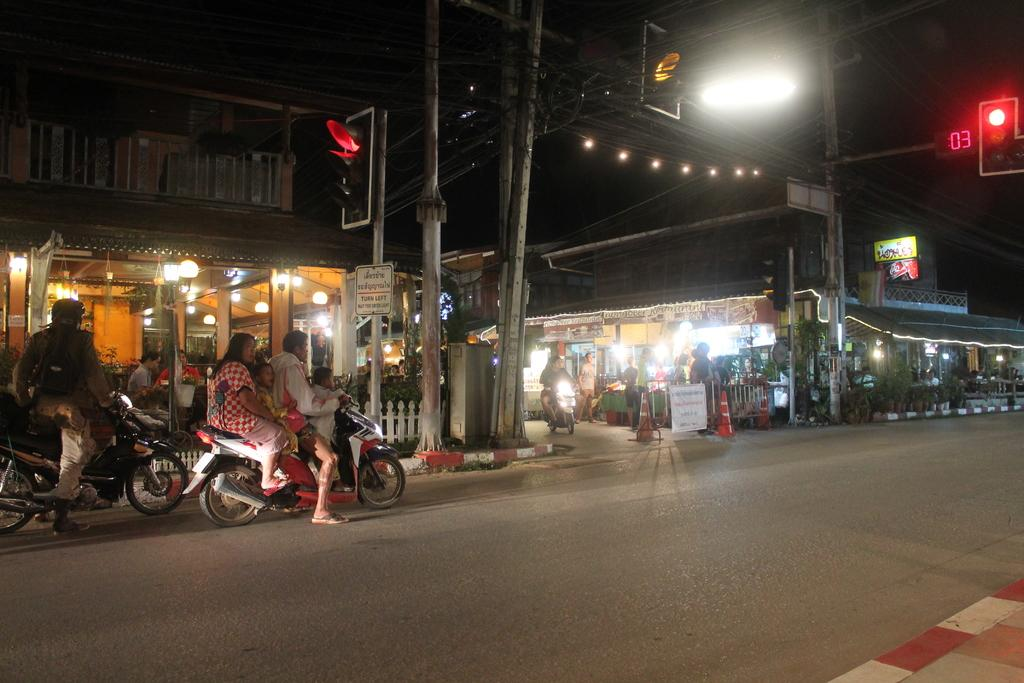What type of structures can be seen in the image? There are buildings in the image. What can be seen illuminating the scene in the image? There are lights in the image. What helps regulate traffic in the image? There are traffic signals in the image. Who is present in the image? There are people in the image. What are some people doing in the image? Some people are sitting on motorcycles. What type of ice can be seen melting on the traffic signals in the image? There is no ice present on the traffic signals in the image. What rule do the people on motorcycles need to follow while driving in the image? The image does not show any driving, so it is not possible to determine what rules the people on motorcycles need to follow. 